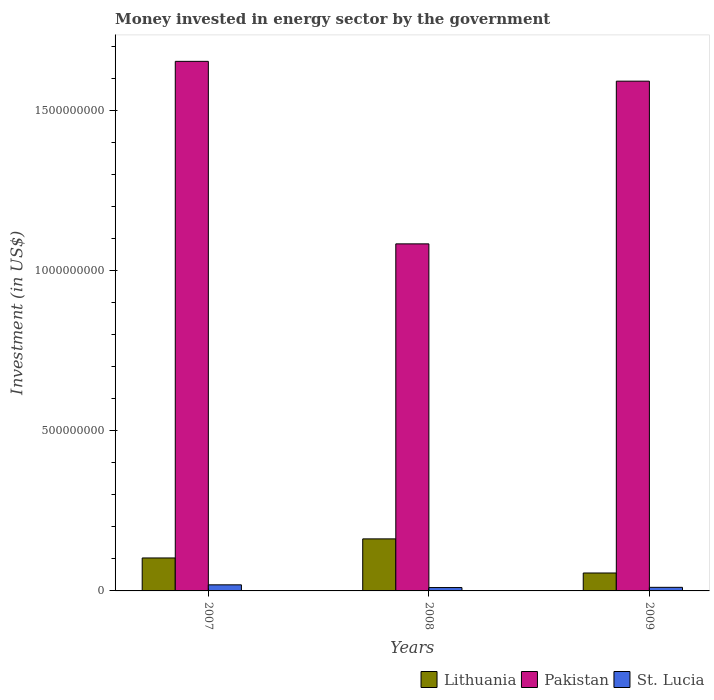How many groups of bars are there?
Provide a short and direct response. 3. Are the number of bars per tick equal to the number of legend labels?
Provide a succinct answer. Yes. How many bars are there on the 2nd tick from the left?
Offer a very short reply. 3. In how many cases, is the number of bars for a given year not equal to the number of legend labels?
Make the answer very short. 0. What is the money spent in energy sector in St. Lucia in 2008?
Your answer should be very brief. 1.05e+07. Across all years, what is the maximum money spent in energy sector in St. Lucia?
Your answer should be very brief. 1.90e+07. Across all years, what is the minimum money spent in energy sector in Pakistan?
Keep it short and to the point. 1.08e+09. In which year was the money spent in energy sector in St. Lucia maximum?
Your answer should be compact. 2007. In which year was the money spent in energy sector in Pakistan minimum?
Ensure brevity in your answer.  2008. What is the total money spent in energy sector in Lithuania in the graph?
Offer a very short reply. 3.22e+08. What is the difference between the money spent in energy sector in Pakistan in 2008 and that in 2009?
Keep it short and to the point. -5.08e+08. What is the difference between the money spent in energy sector in Pakistan in 2007 and the money spent in energy sector in St. Lucia in 2009?
Offer a very short reply. 1.64e+09. What is the average money spent in energy sector in St. Lucia per year?
Offer a terse response. 1.36e+07. In the year 2007, what is the difference between the money spent in energy sector in Lithuania and money spent in energy sector in St. Lucia?
Offer a very short reply. 8.40e+07. What is the ratio of the money spent in energy sector in Lithuania in 2007 to that in 2009?
Keep it short and to the point. 1.84. What is the difference between the highest and the second highest money spent in energy sector in Lithuania?
Offer a terse response. 5.96e+07. What is the difference between the highest and the lowest money spent in energy sector in Lithuania?
Your answer should be compact. 1.07e+08. What does the 1st bar from the left in 2007 represents?
Keep it short and to the point. Lithuania. What does the 1st bar from the right in 2007 represents?
Provide a short and direct response. St. Lucia. Is it the case that in every year, the sum of the money spent in energy sector in Lithuania and money spent in energy sector in St. Lucia is greater than the money spent in energy sector in Pakistan?
Your answer should be very brief. No. How many bars are there?
Give a very brief answer. 9. What is the difference between two consecutive major ticks on the Y-axis?
Make the answer very short. 5.00e+08. Does the graph contain any zero values?
Your answer should be very brief. No. Does the graph contain grids?
Make the answer very short. No. Where does the legend appear in the graph?
Offer a very short reply. Bottom right. How many legend labels are there?
Offer a very short reply. 3. How are the legend labels stacked?
Your response must be concise. Horizontal. What is the title of the graph?
Your answer should be very brief. Money invested in energy sector by the government. Does "Turks and Caicos Islands" appear as one of the legend labels in the graph?
Provide a short and direct response. No. What is the label or title of the Y-axis?
Provide a succinct answer. Investment (in US$). What is the Investment (in US$) of Lithuania in 2007?
Your response must be concise. 1.03e+08. What is the Investment (in US$) in Pakistan in 2007?
Give a very brief answer. 1.65e+09. What is the Investment (in US$) of St. Lucia in 2007?
Ensure brevity in your answer.  1.90e+07. What is the Investment (in US$) of Lithuania in 2008?
Keep it short and to the point. 1.63e+08. What is the Investment (in US$) in Pakistan in 2008?
Your answer should be very brief. 1.08e+09. What is the Investment (in US$) of St. Lucia in 2008?
Make the answer very short. 1.05e+07. What is the Investment (in US$) in Lithuania in 2009?
Provide a succinct answer. 5.60e+07. What is the Investment (in US$) of Pakistan in 2009?
Offer a very short reply. 1.59e+09. What is the Investment (in US$) of St. Lucia in 2009?
Provide a short and direct response. 1.12e+07. Across all years, what is the maximum Investment (in US$) of Lithuania?
Your response must be concise. 1.63e+08. Across all years, what is the maximum Investment (in US$) in Pakistan?
Give a very brief answer. 1.65e+09. Across all years, what is the maximum Investment (in US$) in St. Lucia?
Your answer should be very brief. 1.90e+07. Across all years, what is the minimum Investment (in US$) of Lithuania?
Provide a succinct answer. 5.60e+07. Across all years, what is the minimum Investment (in US$) of Pakistan?
Your response must be concise. 1.08e+09. Across all years, what is the minimum Investment (in US$) in St. Lucia?
Your answer should be very brief. 1.05e+07. What is the total Investment (in US$) in Lithuania in the graph?
Provide a short and direct response. 3.22e+08. What is the total Investment (in US$) of Pakistan in the graph?
Your answer should be compact. 4.33e+09. What is the total Investment (in US$) of St. Lucia in the graph?
Your response must be concise. 4.07e+07. What is the difference between the Investment (in US$) in Lithuania in 2007 and that in 2008?
Your answer should be very brief. -5.96e+07. What is the difference between the Investment (in US$) in Pakistan in 2007 and that in 2008?
Provide a succinct answer. 5.70e+08. What is the difference between the Investment (in US$) of St. Lucia in 2007 and that in 2008?
Your answer should be very brief. 8.50e+06. What is the difference between the Investment (in US$) in Lithuania in 2007 and that in 2009?
Make the answer very short. 4.70e+07. What is the difference between the Investment (in US$) of Pakistan in 2007 and that in 2009?
Make the answer very short. 6.19e+07. What is the difference between the Investment (in US$) of St. Lucia in 2007 and that in 2009?
Offer a terse response. 7.80e+06. What is the difference between the Investment (in US$) of Lithuania in 2008 and that in 2009?
Provide a short and direct response. 1.07e+08. What is the difference between the Investment (in US$) in Pakistan in 2008 and that in 2009?
Provide a succinct answer. -5.08e+08. What is the difference between the Investment (in US$) of St. Lucia in 2008 and that in 2009?
Your answer should be very brief. -7.00e+05. What is the difference between the Investment (in US$) of Lithuania in 2007 and the Investment (in US$) of Pakistan in 2008?
Give a very brief answer. -9.81e+08. What is the difference between the Investment (in US$) in Lithuania in 2007 and the Investment (in US$) in St. Lucia in 2008?
Provide a short and direct response. 9.25e+07. What is the difference between the Investment (in US$) of Pakistan in 2007 and the Investment (in US$) of St. Lucia in 2008?
Ensure brevity in your answer.  1.64e+09. What is the difference between the Investment (in US$) of Lithuania in 2007 and the Investment (in US$) of Pakistan in 2009?
Ensure brevity in your answer.  -1.49e+09. What is the difference between the Investment (in US$) of Lithuania in 2007 and the Investment (in US$) of St. Lucia in 2009?
Give a very brief answer. 9.18e+07. What is the difference between the Investment (in US$) of Pakistan in 2007 and the Investment (in US$) of St. Lucia in 2009?
Make the answer very short. 1.64e+09. What is the difference between the Investment (in US$) in Lithuania in 2008 and the Investment (in US$) in Pakistan in 2009?
Your answer should be very brief. -1.43e+09. What is the difference between the Investment (in US$) in Lithuania in 2008 and the Investment (in US$) in St. Lucia in 2009?
Provide a short and direct response. 1.51e+08. What is the difference between the Investment (in US$) of Pakistan in 2008 and the Investment (in US$) of St. Lucia in 2009?
Make the answer very short. 1.07e+09. What is the average Investment (in US$) of Lithuania per year?
Give a very brief answer. 1.07e+08. What is the average Investment (in US$) of Pakistan per year?
Keep it short and to the point. 1.44e+09. What is the average Investment (in US$) in St. Lucia per year?
Your answer should be compact. 1.36e+07. In the year 2007, what is the difference between the Investment (in US$) of Lithuania and Investment (in US$) of Pakistan?
Your answer should be very brief. -1.55e+09. In the year 2007, what is the difference between the Investment (in US$) of Lithuania and Investment (in US$) of St. Lucia?
Your answer should be very brief. 8.40e+07. In the year 2007, what is the difference between the Investment (in US$) of Pakistan and Investment (in US$) of St. Lucia?
Ensure brevity in your answer.  1.64e+09. In the year 2008, what is the difference between the Investment (in US$) in Lithuania and Investment (in US$) in Pakistan?
Provide a succinct answer. -9.22e+08. In the year 2008, what is the difference between the Investment (in US$) in Lithuania and Investment (in US$) in St. Lucia?
Provide a short and direct response. 1.52e+08. In the year 2008, what is the difference between the Investment (in US$) of Pakistan and Investment (in US$) of St. Lucia?
Provide a succinct answer. 1.07e+09. In the year 2009, what is the difference between the Investment (in US$) in Lithuania and Investment (in US$) in Pakistan?
Make the answer very short. -1.54e+09. In the year 2009, what is the difference between the Investment (in US$) in Lithuania and Investment (in US$) in St. Lucia?
Your answer should be very brief. 4.48e+07. In the year 2009, what is the difference between the Investment (in US$) in Pakistan and Investment (in US$) in St. Lucia?
Make the answer very short. 1.58e+09. What is the ratio of the Investment (in US$) in Lithuania in 2007 to that in 2008?
Your answer should be compact. 0.63. What is the ratio of the Investment (in US$) in Pakistan in 2007 to that in 2008?
Your answer should be very brief. 1.53. What is the ratio of the Investment (in US$) of St. Lucia in 2007 to that in 2008?
Offer a very short reply. 1.81. What is the ratio of the Investment (in US$) of Lithuania in 2007 to that in 2009?
Offer a terse response. 1.84. What is the ratio of the Investment (in US$) in Pakistan in 2007 to that in 2009?
Provide a short and direct response. 1.04. What is the ratio of the Investment (in US$) of St. Lucia in 2007 to that in 2009?
Your answer should be very brief. 1.7. What is the ratio of the Investment (in US$) of Lithuania in 2008 to that in 2009?
Provide a succinct answer. 2.9. What is the ratio of the Investment (in US$) in Pakistan in 2008 to that in 2009?
Give a very brief answer. 0.68. What is the ratio of the Investment (in US$) of St. Lucia in 2008 to that in 2009?
Provide a short and direct response. 0.94. What is the difference between the highest and the second highest Investment (in US$) of Lithuania?
Give a very brief answer. 5.96e+07. What is the difference between the highest and the second highest Investment (in US$) in Pakistan?
Make the answer very short. 6.19e+07. What is the difference between the highest and the second highest Investment (in US$) in St. Lucia?
Keep it short and to the point. 7.80e+06. What is the difference between the highest and the lowest Investment (in US$) in Lithuania?
Your answer should be very brief. 1.07e+08. What is the difference between the highest and the lowest Investment (in US$) of Pakistan?
Keep it short and to the point. 5.70e+08. What is the difference between the highest and the lowest Investment (in US$) of St. Lucia?
Provide a succinct answer. 8.50e+06. 